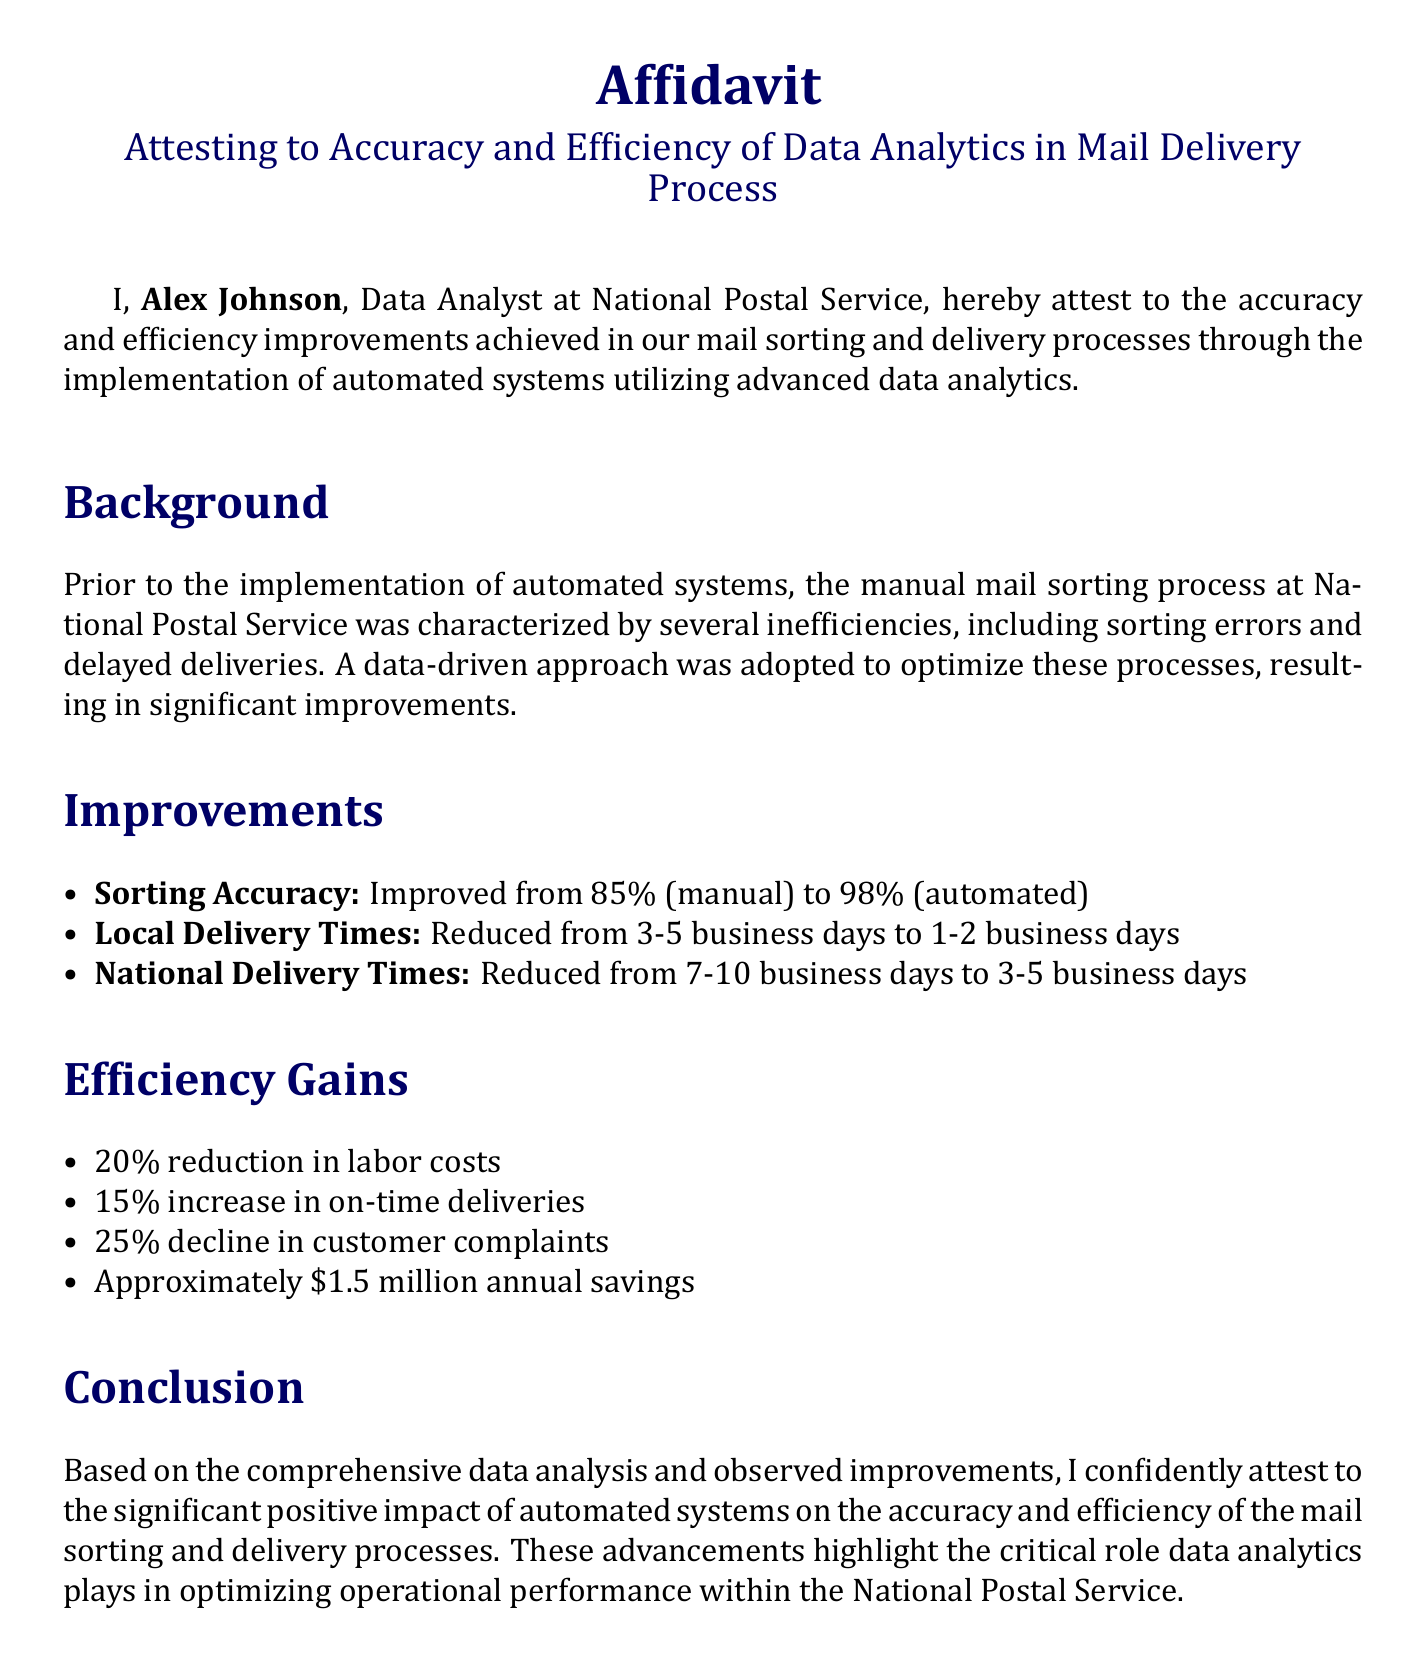What is the sorting accuracy before automation? The sorting accuracy before automation is explicitly stated as 85%.
Answer: 85% What is the sorting accuracy after automation? The sorting accuracy after automation is stated as 98%.
Answer: 98% Who is the affiant of the document? The document identifies Alex Johnson as the affiant, who is the Data Analyst at National Postal Service.
Answer: Alex Johnson What were the local delivery times before automation? The local delivery times before automation are noted as 3-5 business days.
Answer: 3-5 business days What percentage of labor cost reduction was achieved? The document states a 20% reduction in labor costs.
Answer: 20% What was the annual savings reported after automation? The affidavit mentions approximately $1.5 million in annual savings.
Answer: $1.5 million What is the increase in on-time deliveries after implementing automated systems? The affidavit cites a 15% increase in on-time deliveries.
Answer: 15% What were the national delivery times after automation? National delivery times after automation are reported as 3-5 business days.
Answer: 3-5 business days What is the date of the affidavit? The date of the affidavit is specified as November 1, 2023.
Answer: November 1, 2023 